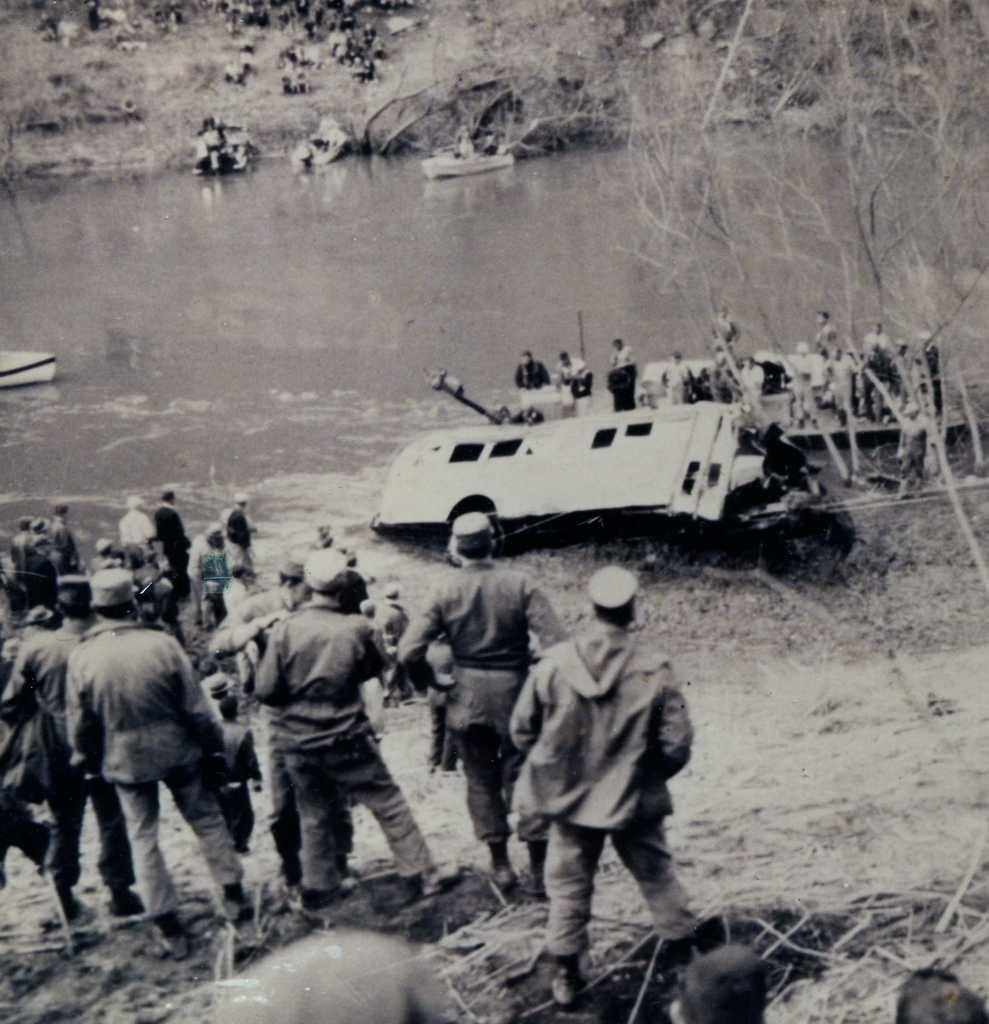What is the color scheme of the image? The image is black and white. Who or what can be seen in the image? There are people in the image. What natural feature is visible in the image? Groundwater is visible in the image. What type of transportation is present in the image? Boats are present in the image. What type of vegetation is visible in the image? Trees are visible in the image. Are there any other objects or features in the image? Yes, there are other objects in the image. What type of hole can be seen in the image? There is no hole present in the image. What type of cloth is being used to burn in the image? There is no cloth or burning activity present in the image. 